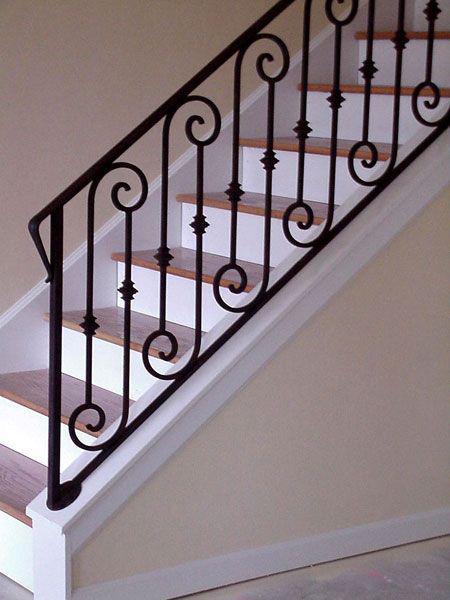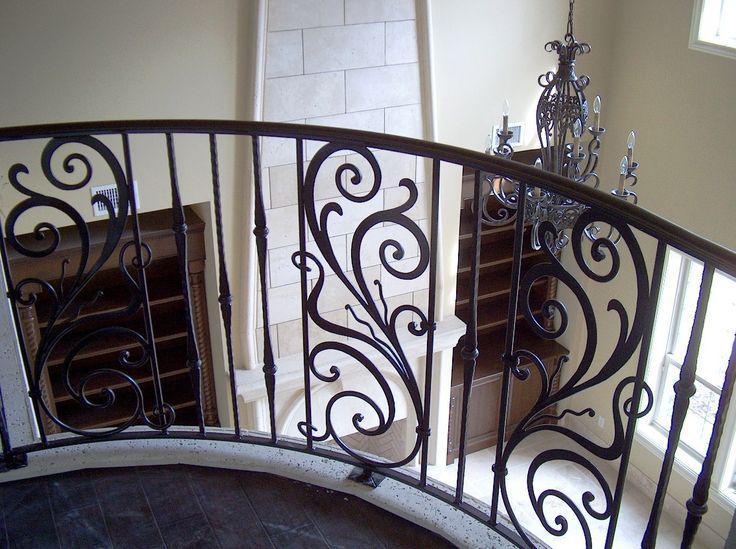The first image is the image on the left, the second image is the image on the right. For the images displayed, is the sentence "In at least one image there is a staircase with brown and white steps with metal rods with curled and s shapes." factually correct? Answer yes or no. Yes. 